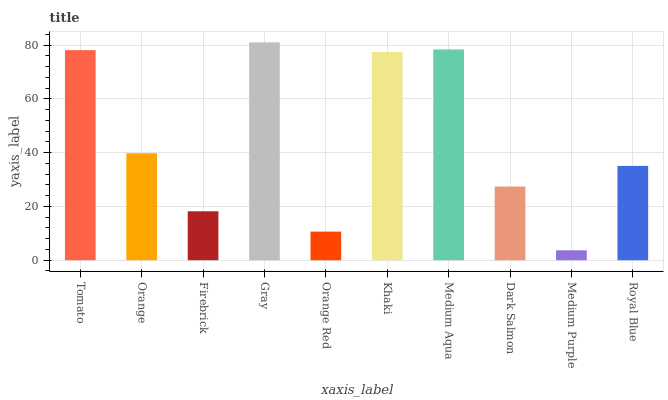Is Orange the minimum?
Answer yes or no. No. Is Orange the maximum?
Answer yes or no. No. Is Tomato greater than Orange?
Answer yes or no. Yes. Is Orange less than Tomato?
Answer yes or no. Yes. Is Orange greater than Tomato?
Answer yes or no. No. Is Tomato less than Orange?
Answer yes or no. No. Is Orange the high median?
Answer yes or no. Yes. Is Royal Blue the low median?
Answer yes or no. Yes. Is Dark Salmon the high median?
Answer yes or no. No. Is Gray the low median?
Answer yes or no. No. 